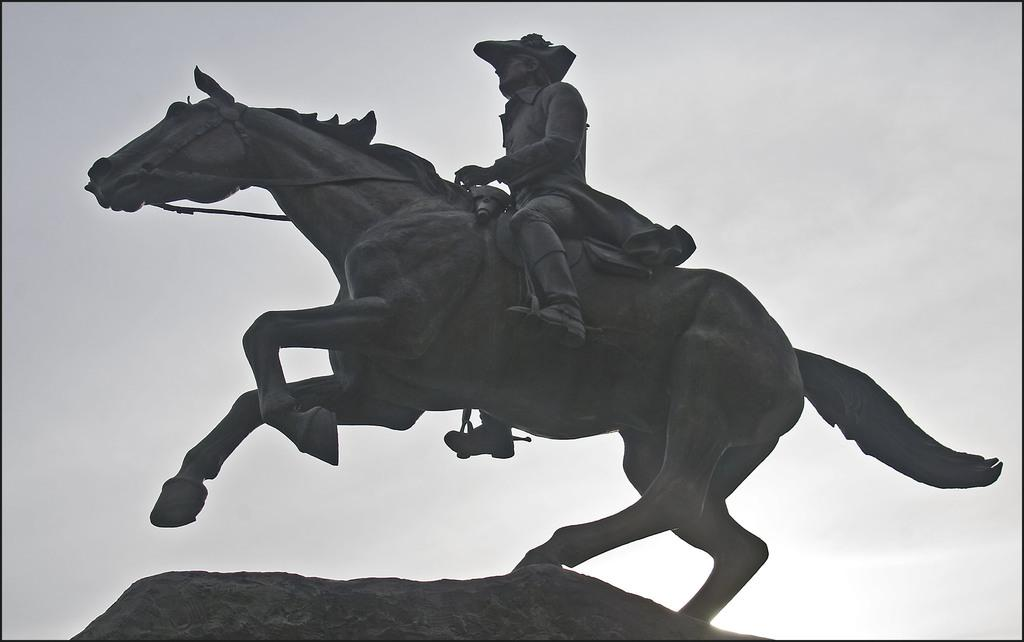What is the main subject of the image? The main subject of the image is a horse statue. Is there anyone on the horse statue? Yes, there is a man on the horse statue. What type of maid is present in the image? There is no maid present in the image; it features a horse statue with a man on it. Is the man on the horse statue in jail? There is no indication in the image that the man on the horse statue is in jail. 